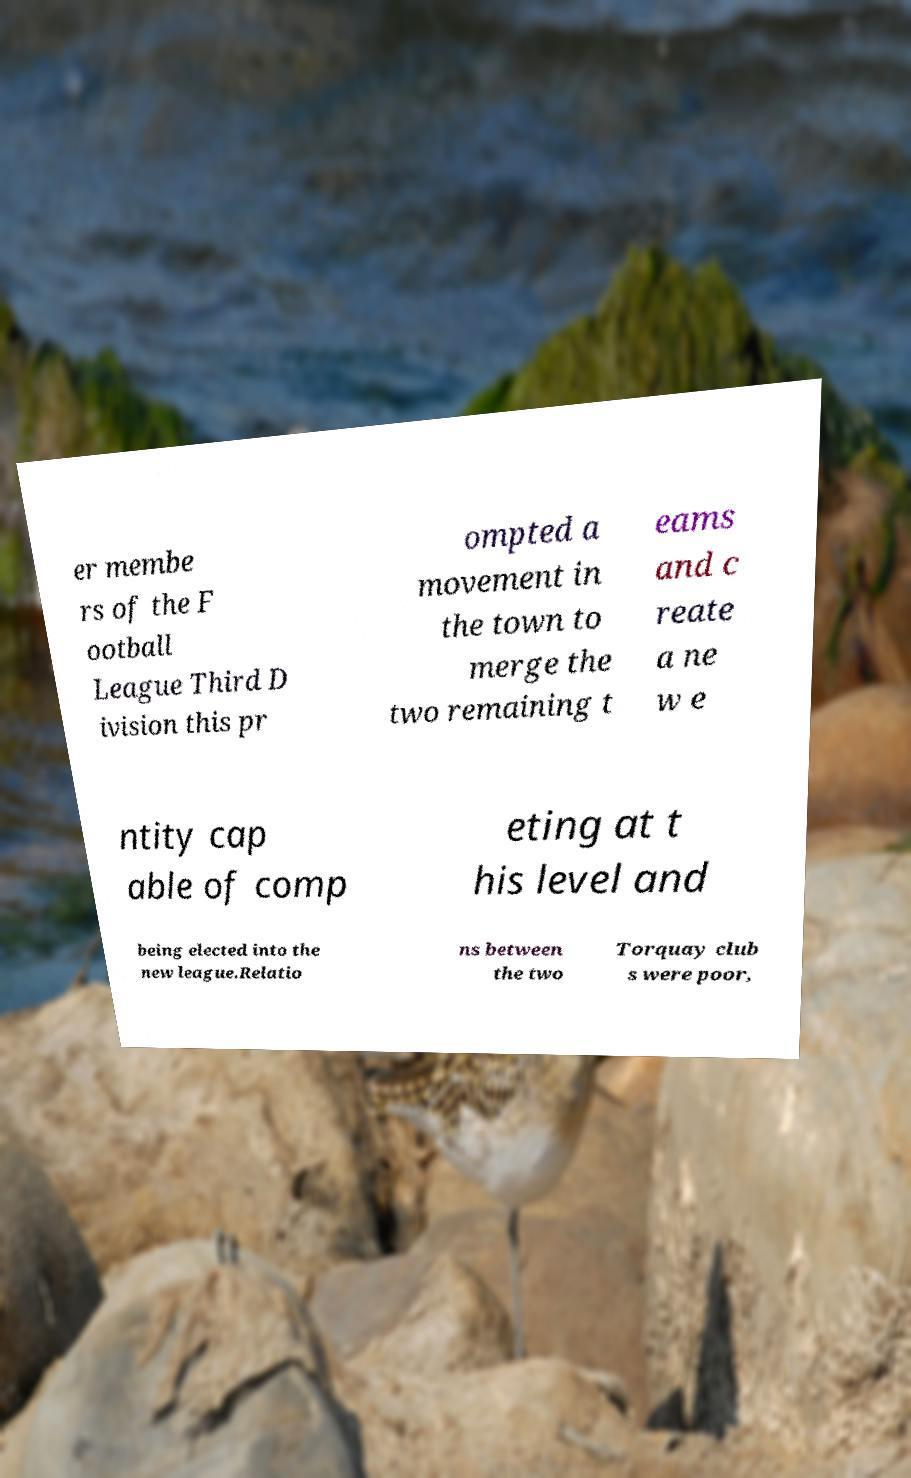What messages or text are displayed in this image? I need them in a readable, typed format. er membe rs of the F ootball League Third D ivision this pr ompted a movement in the town to merge the two remaining t eams and c reate a ne w e ntity cap able of comp eting at t his level and being elected into the new league.Relatio ns between the two Torquay club s were poor, 